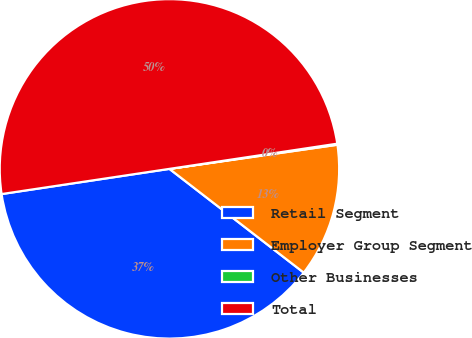Convert chart to OTSL. <chart><loc_0><loc_0><loc_500><loc_500><pie_chart><fcel>Retail Segment<fcel>Employer Group Segment<fcel>Other Businesses<fcel>Total<nl><fcel>37.16%<fcel>12.74%<fcel>0.1%<fcel>50.0%<nl></chart> 